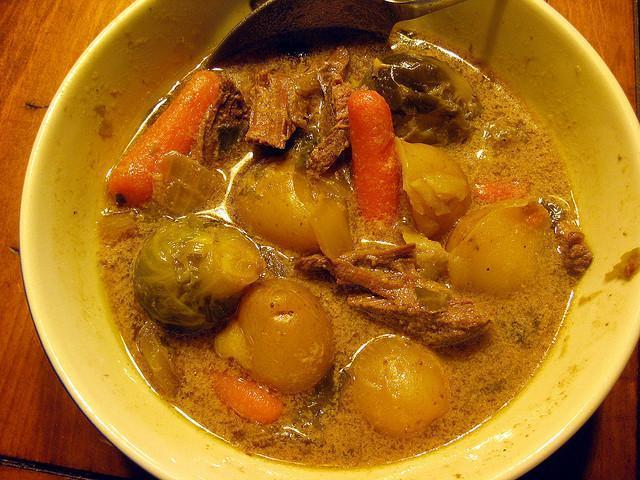How many carrots are visible?
Give a very brief answer. 3. 